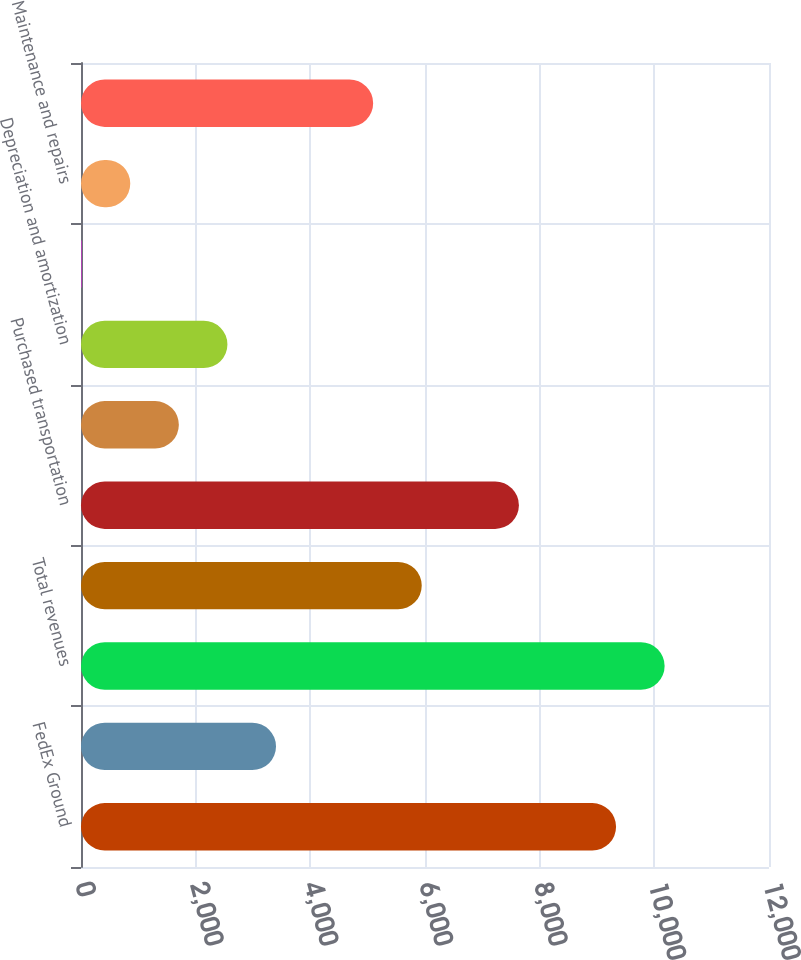<chart> <loc_0><loc_0><loc_500><loc_500><bar_chart><fcel>FedEx Ground<fcel>FedEx SmartPost<fcel>Total revenues<fcel>Salaries and employee benefits<fcel>Purchased transportation<fcel>Rentals<fcel>Depreciation and amortization<fcel>Fuel<fcel>Maintenance and repairs<fcel>Intercompany charges (1)<nl><fcel>9332.3<fcel>3401.2<fcel>10179.6<fcel>5943.1<fcel>7637.7<fcel>1706.6<fcel>2553.9<fcel>12<fcel>859.3<fcel>5095.8<nl></chart> 